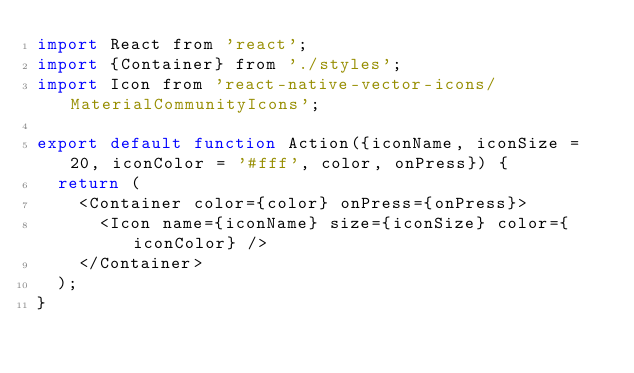Convert code to text. <code><loc_0><loc_0><loc_500><loc_500><_JavaScript_>import React from 'react';
import {Container} from './styles';
import Icon from 'react-native-vector-icons/MaterialCommunityIcons';

export default function Action({iconName, iconSize = 20, iconColor = '#fff', color, onPress}) {
  return (
    <Container color={color} onPress={onPress}>
      <Icon name={iconName} size={iconSize} color={iconColor} />
    </Container>
  );
}
</code> 